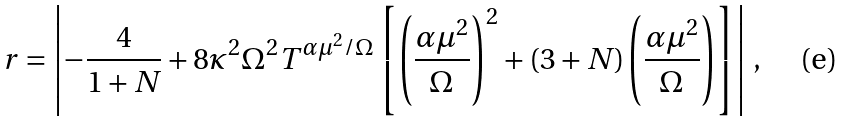Convert formula to latex. <formula><loc_0><loc_0><loc_500><loc_500>r = \left | - \frac { 4 } { 1 + N } + 8 \kappa ^ { 2 } \Omega ^ { 2 } T ^ { \alpha \mu ^ { 2 } / \Omega } \left [ \left ( \frac { \alpha \mu ^ { 2 } } { \Omega } \right ) ^ { 2 } + ( 3 + N ) \left ( \frac { \alpha \mu ^ { 2 } } { \Omega } \right ) \right ] \right | \, ,</formula> 